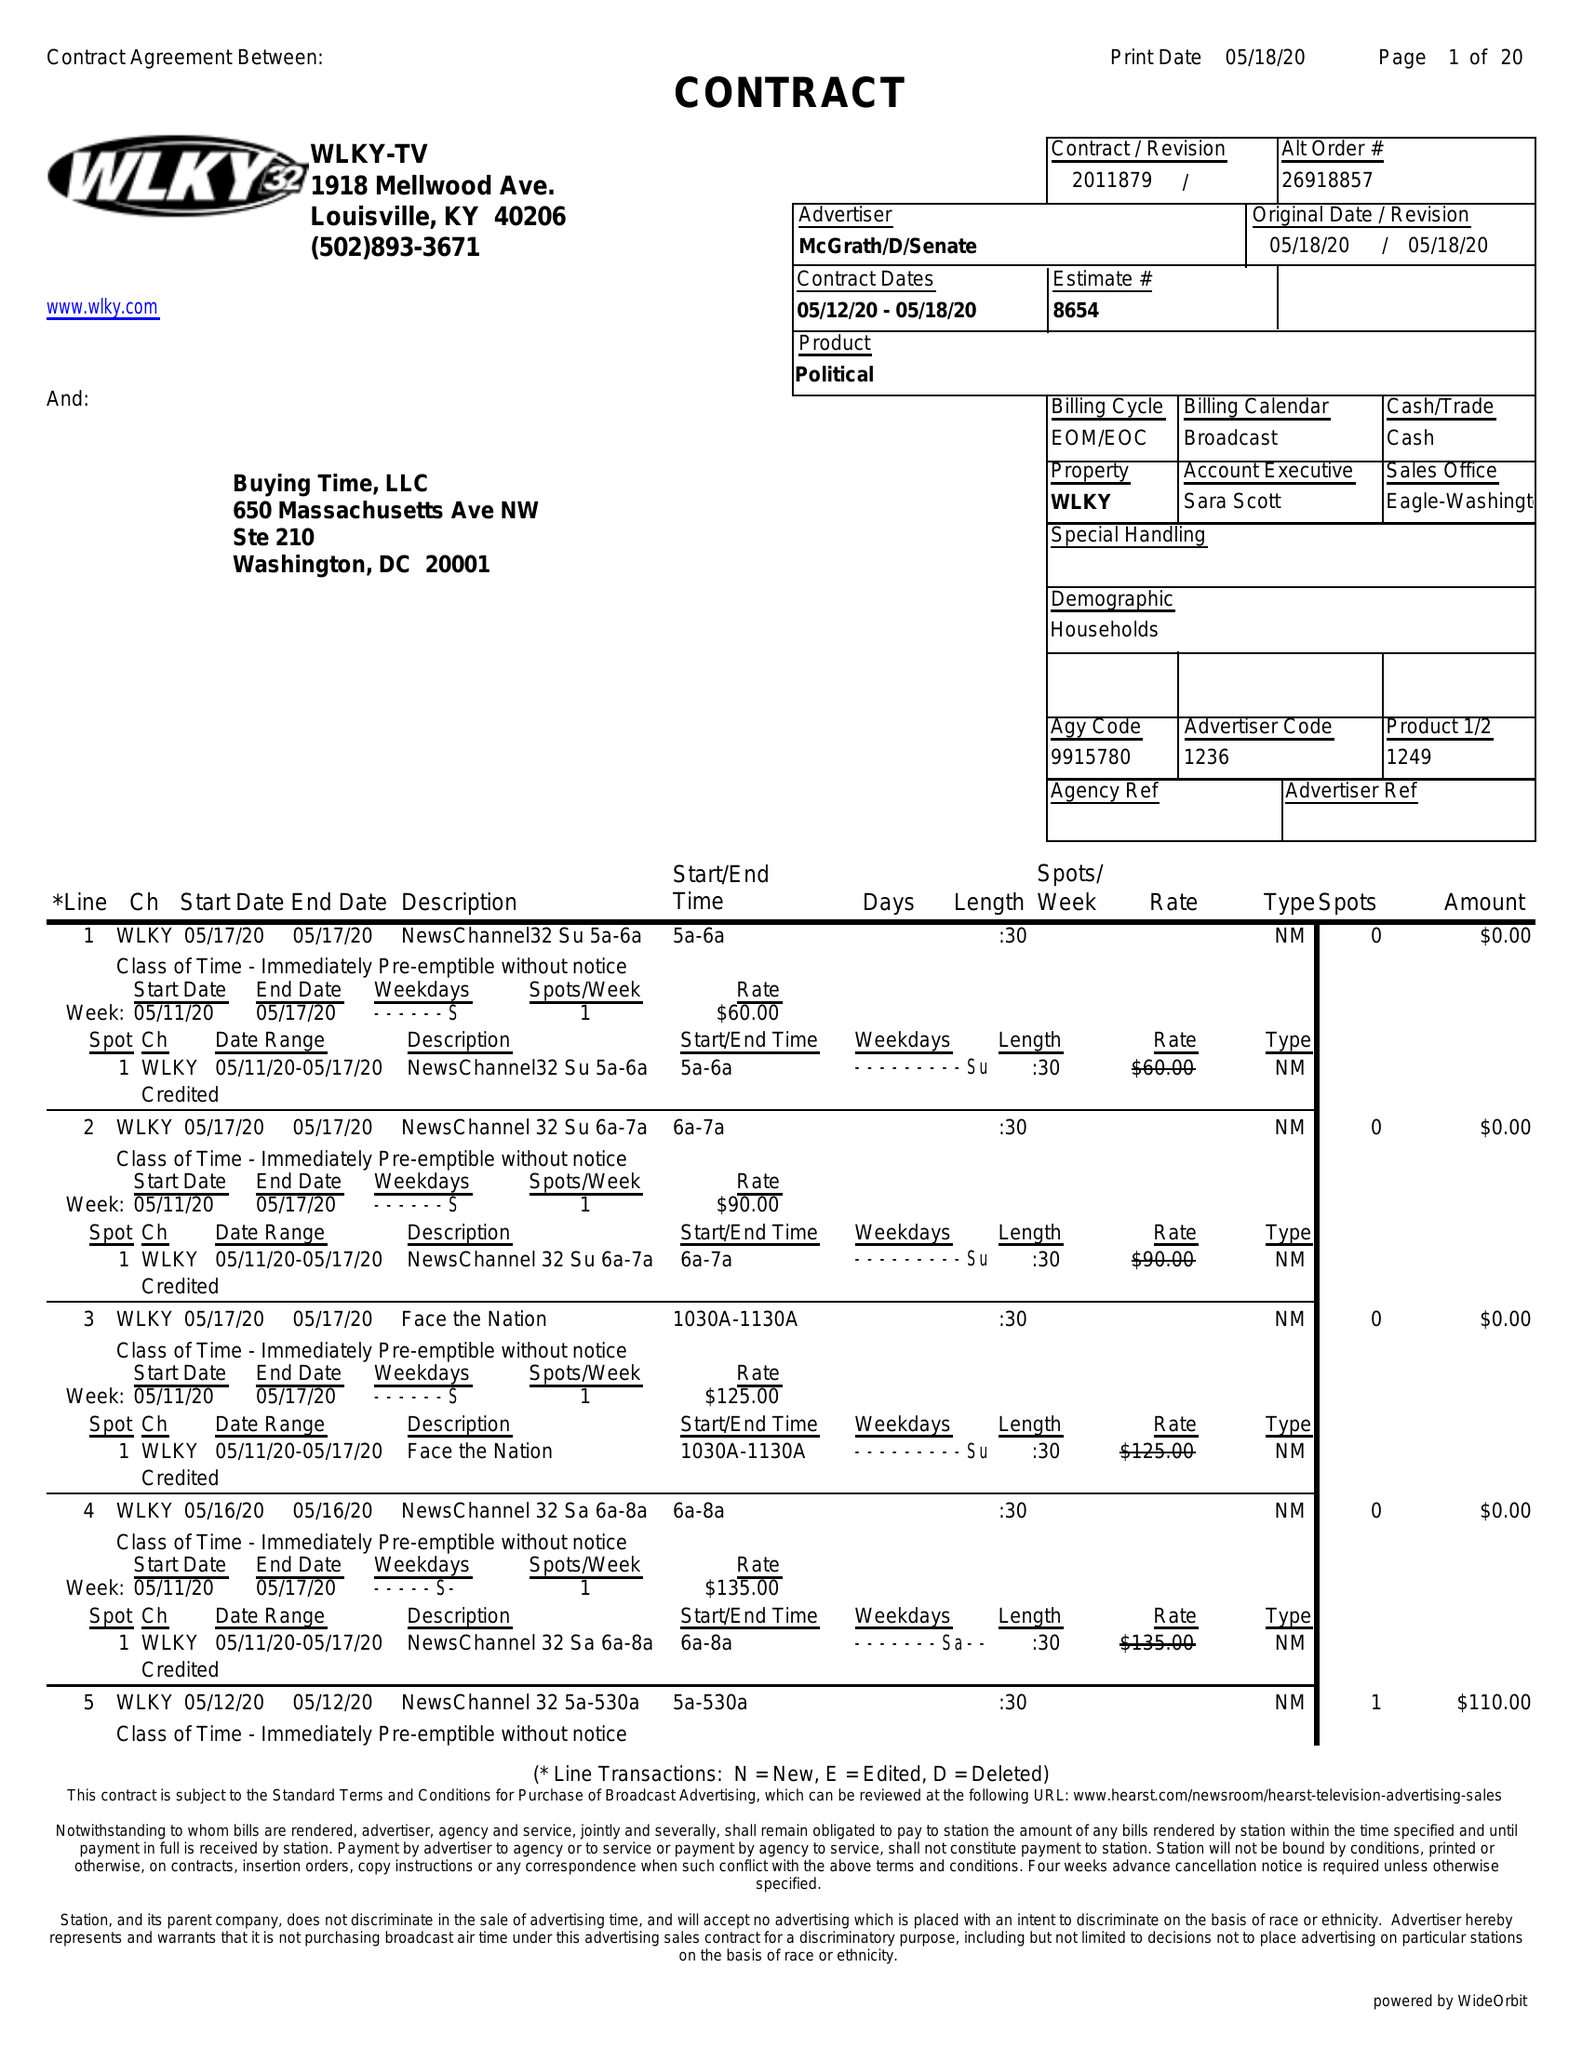What is the value for the contract_num?
Answer the question using a single word or phrase. 2011879 